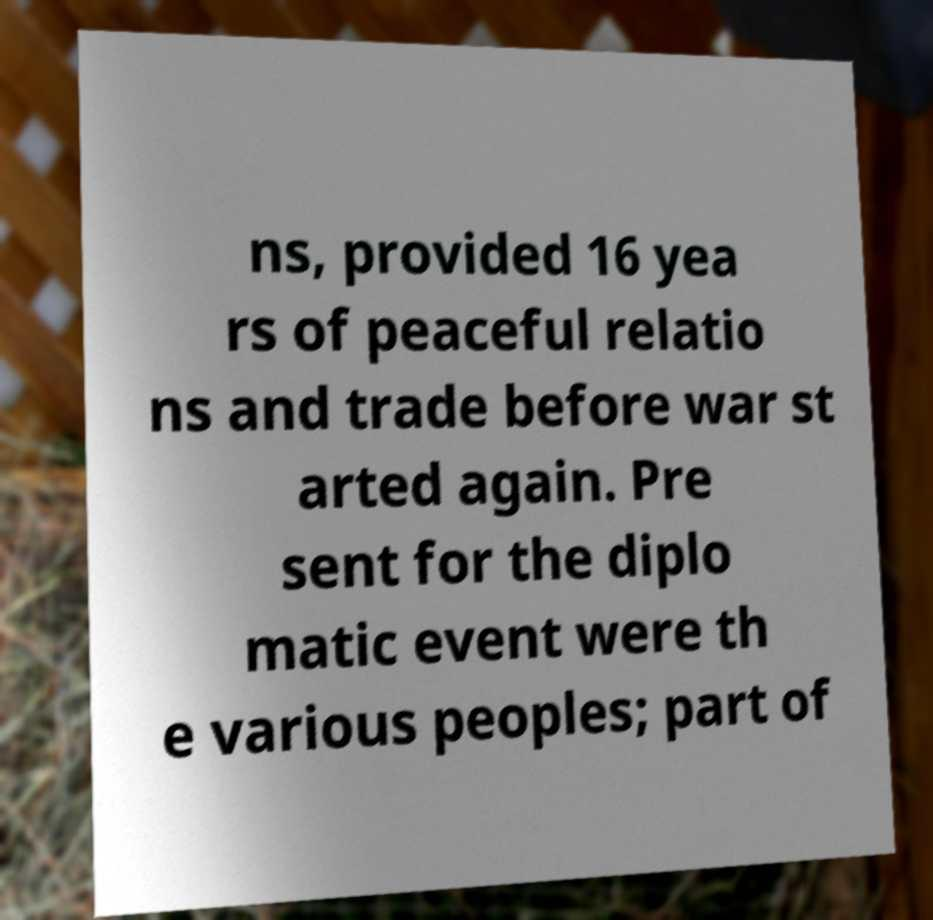There's text embedded in this image that I need extracted. Can you transcribe it verbatim? ns, provided 16 yea rs of peaceful relatio ns and trade before war st arted again. Pre sent for the diplo matic event were th e various peoples; part of 